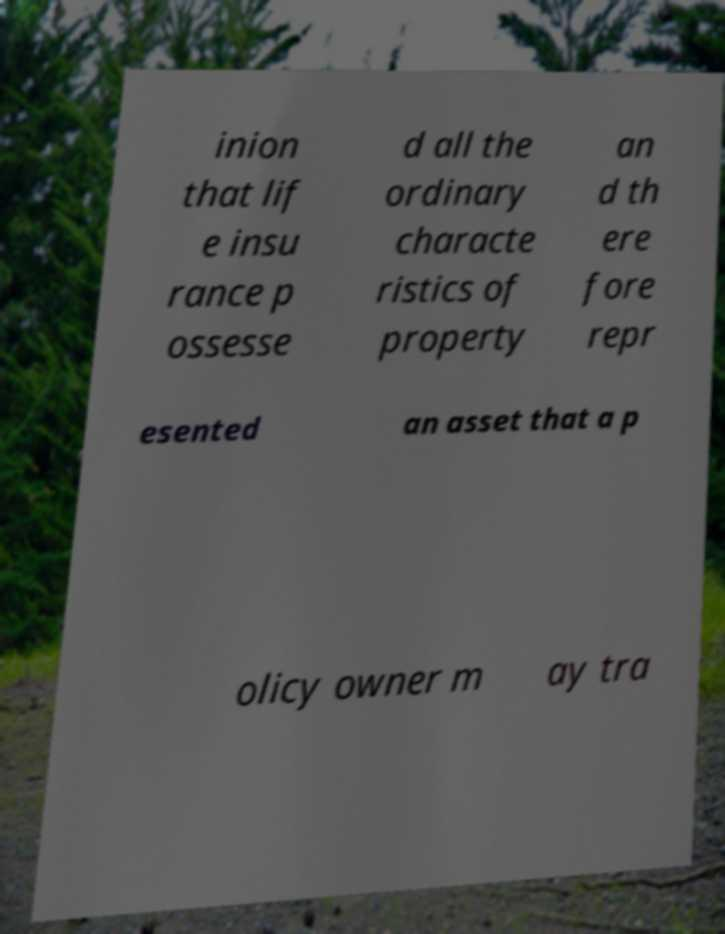Please read and relay the text visible in this image. What does it say? inion that lif e insu rance p ossesse d all the ordinary characte ristics of property an d th ere fore repr esented an asset that a p olicy owner m ay tra 